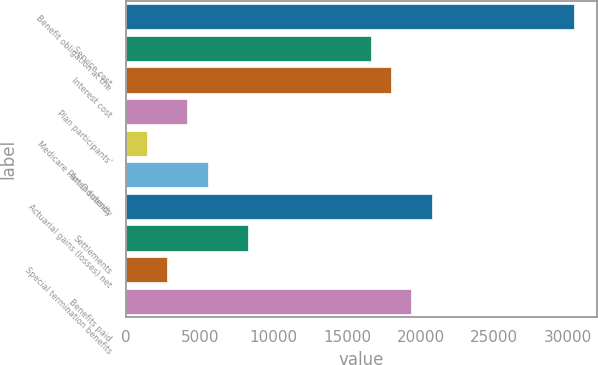Convert chart to OTSL. <chart><loc_0><loc_0><loc_500><loc_500><bar_chart><fcel>Benefit obligation at the<fcel>Service cost<fcel>Interest cost<fcel>Plan participants'<fcel>Medicare Part D subsidy<fcel>Amendments<fcel>Actuarial gains (losses) net<fcel>Settlements<fcel>Special termination benefits<fcel>Benefits paid<nl><fcel>30440.9<fcel>16605.1<fcel>17988.7<fcel>4152.9<fcel>1385.74<fcel>5536.48<fcel>20755.9<fcel>8303.64<fcel>2769.32<fcel>19372.3<nl></chart> 